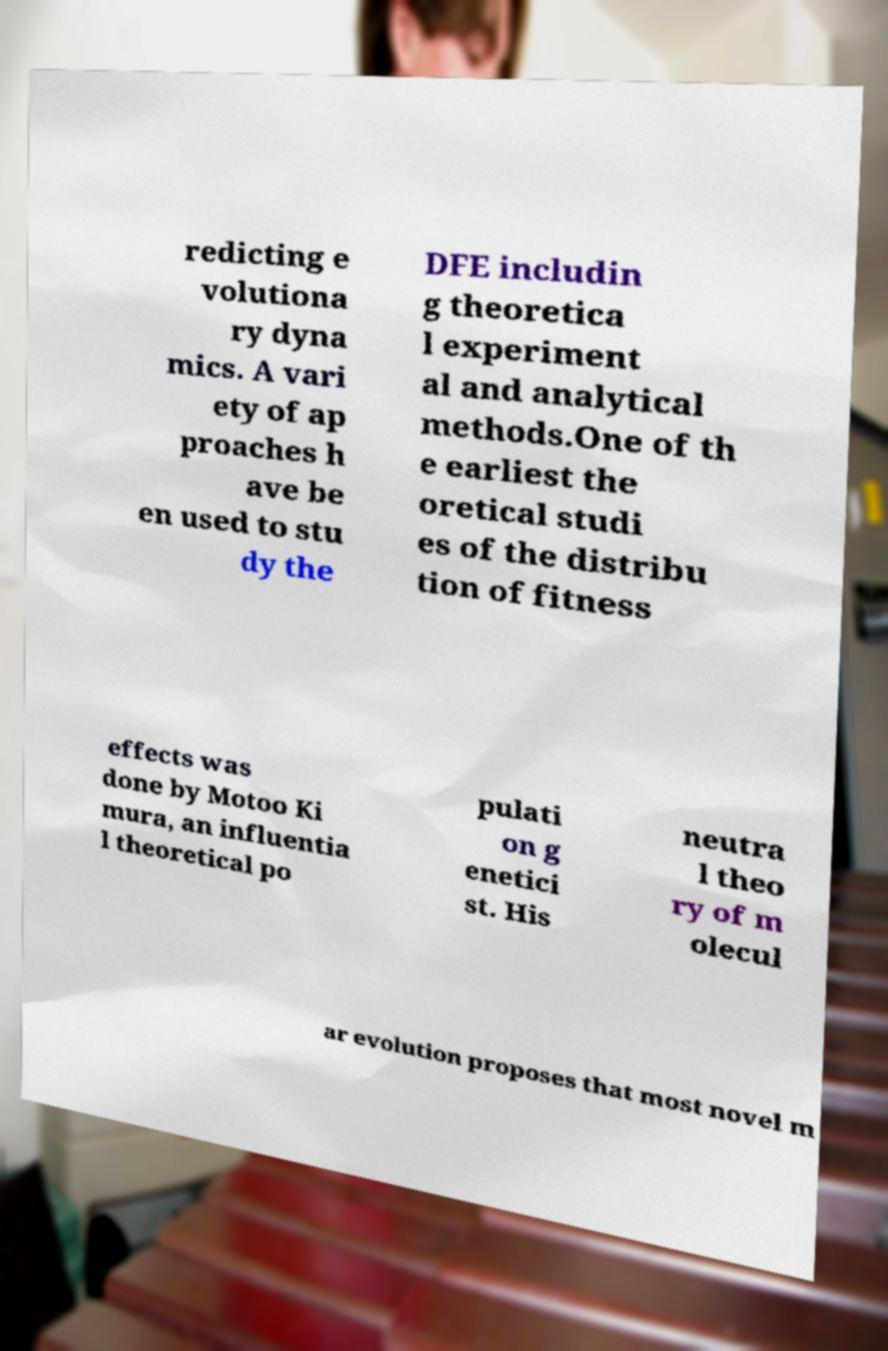Can you accurately transcribe the text from the provided image for me? redicting e volutiona ry dyna mics. A vari ety of ap proaches h ave be en used to stu dy the DFE includin g theoretica l experiment al and analytical methods.One of th e earliest the oretical studi es of the distribu tion of fitness effects was done by Motoo Ki mura, an influentia l theoretical po pulati on g enetici st. His neutra l theo ry of m olecul ar evolution proposes that most novel m 